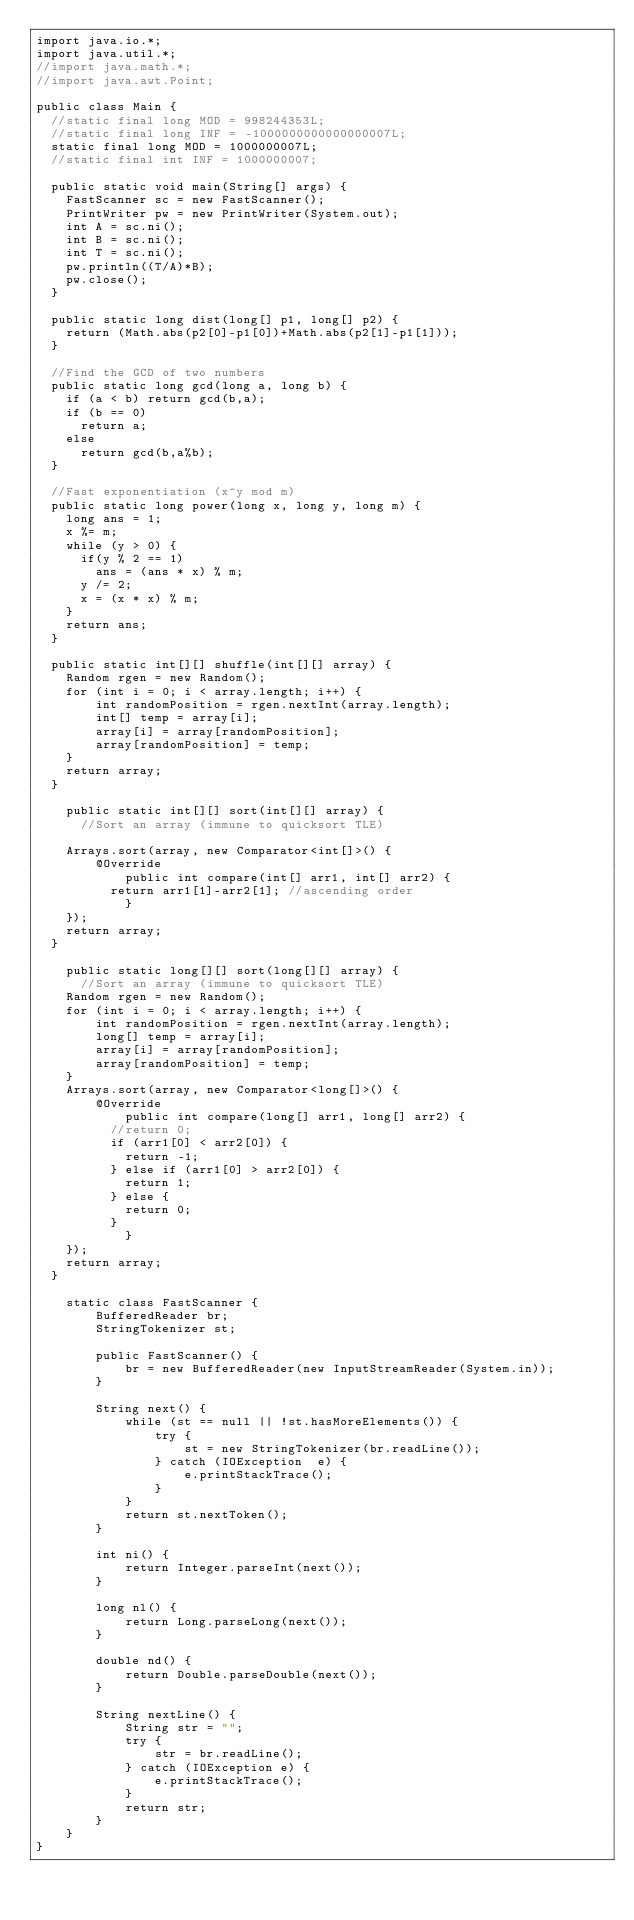Convert code to text. <code><loc_0><loc_0><loc_500><loc_500><_Java_>import java.io.*;
import java.util.*;
//import java.math.*;
//import java.awt.Point;
 
public class Main {
	//static final long MOD = 998244353L;
	//static final long INF = -1000000000000000007L;
	static final long MOD = 1000000007L;
	//static final int INF = 1000000007;
	
	public static void main(String[] args) {
		FastScanner sc = new FastScanner();
		PrintWriter pw = new PrintWriter(System.out);
		int A = sc.ni();
		int B = sc.ni();
		int T = sc.ni();
		pw.println((T/A)*B);
		pw.close();
	}
	
	public static long dist(long[] p1, long[] p2) {
		return (Math.abs(p2[0]-p1[0])+Math.abs(p2[1]-p1[1]));
	}
	
	//Find the GCD of two numbers
	public static long gcd(long a, long b) {
		if (a < b) return gcd(b,a);
		if (b == 0)
			return a;
		else
			return gcd(b,a%b);
	}
	
	//Fast exponentiation (x^y mod m)
	public static long power(long x, long y, long m) { 
		long ans = 1;
		x %= m;
		while (y > 0) { 
			if(y % 2 == 1) 
				ans = (ans * x) % m; 
			y /= 2;  
			x = (x * x) % m;
		} 
		return ans; 
	}
	
	public static int[][] shuffle(int[][] array) {
		Random rgen = new Random();
		for (int i = 0; i < array.length; i++) {
		    int randomPosition = rgen.nextInt(array.length);
		    int[] temp = array[i];
		    array[i] = array[randomPosition];
		    array[randomPosition] = temp;
		}
		return array;
	}
	
    public static int[][] sort(int[][] array) {
    	//Sort an array (immune to quicksort TLE)
 
		Arrays.sort(array, new Comparator<int[]>() {
			  @Override
        	  public int compare(int[] arr1, int[] arr2) {
				  return arr1[1]-arr2[1]; //ascending order
	          }
		});
		return array;
	}
    
    public static long[][] sort(long[][] array) {
    	//Sort an array (immune to quicksort TLE)
		Random rgen = new Random();
		for (int i = 0; i < array.length; i++) {
		    int randomPosition = rgen.nextInt(array.length);
		    long[] temp = array[i];
		    array[i] = array[randomPosition];
		    array[randomPosition] = temp;
		}
		Arrays.sort(array, new Comparator<long[]>() {
			  @Override
        	  public int compare(long[] arr1, long[] arr2) {
				  //return 0;
				  if (arr1[0] < arr2[0]) {
					  return -1;
				  } else if (arr1[0] > arr2[0]) {
					  return 1;
				  } else {
					  return 0;
				  }
	          }
		});
		return array;
	}
    
    static class FastScanner { 
        BufferedReader br; 
        StringTokenizer st; 
  
        public FastScanner() { 
            br = new BufferedReader(new InputStreamReader(System.in)); 
        } 
  
        String next() { 
            while (st == null || !st.hasMoreElements()) { 
                try { 
                    st = new StringTokenizer(br.readLine());
                } catch (IOException  e) { 
                    e.printStackTrace(); 
                } 
            } 
            return st.nextToken(); 
        } 
  
        int ni() { 
            return Integer.parseInt(next()); 
        } 
  
        long nl() { 
            return Long.parseLong(next()); 
        } 
  
        double nd() { 
            return Double.parseDouble(next()); 
        } 
  
        String nextLine() { 
            String str = ""; 
            try { 
                str = br.readLine(); 
            } catch (IOException e) {
                e.printStackTrace(); 
            } 
            return str;
        }
    }
}</code> 